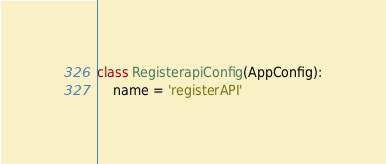<code> <loc_0><loc_0><loc_500><loc_500><_Python_>
class RegisterapiConfig(AppConfig):
    name = 'registerAPI'
</code> 